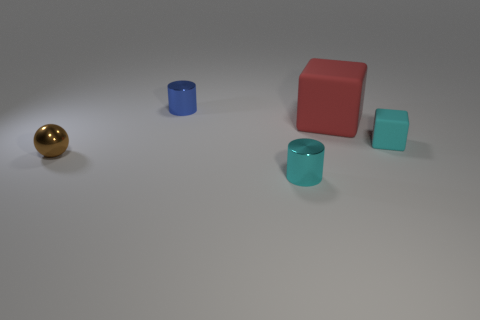Add 5 tiny blue cylinders. How many objects exist? 10 Subtract all cylinders. How many objects are left? 3 Add 1 small cyan matte objects. How many small cyan matte objects are left? 2 Add 4 tiny cubes. How many tiny cubes exist? 5 Subtract 0 brown cylinders. How many objects are left? 5 Subtract all blue matte things. Subtract all tiny brown metallic things. How many objects are left? 4 